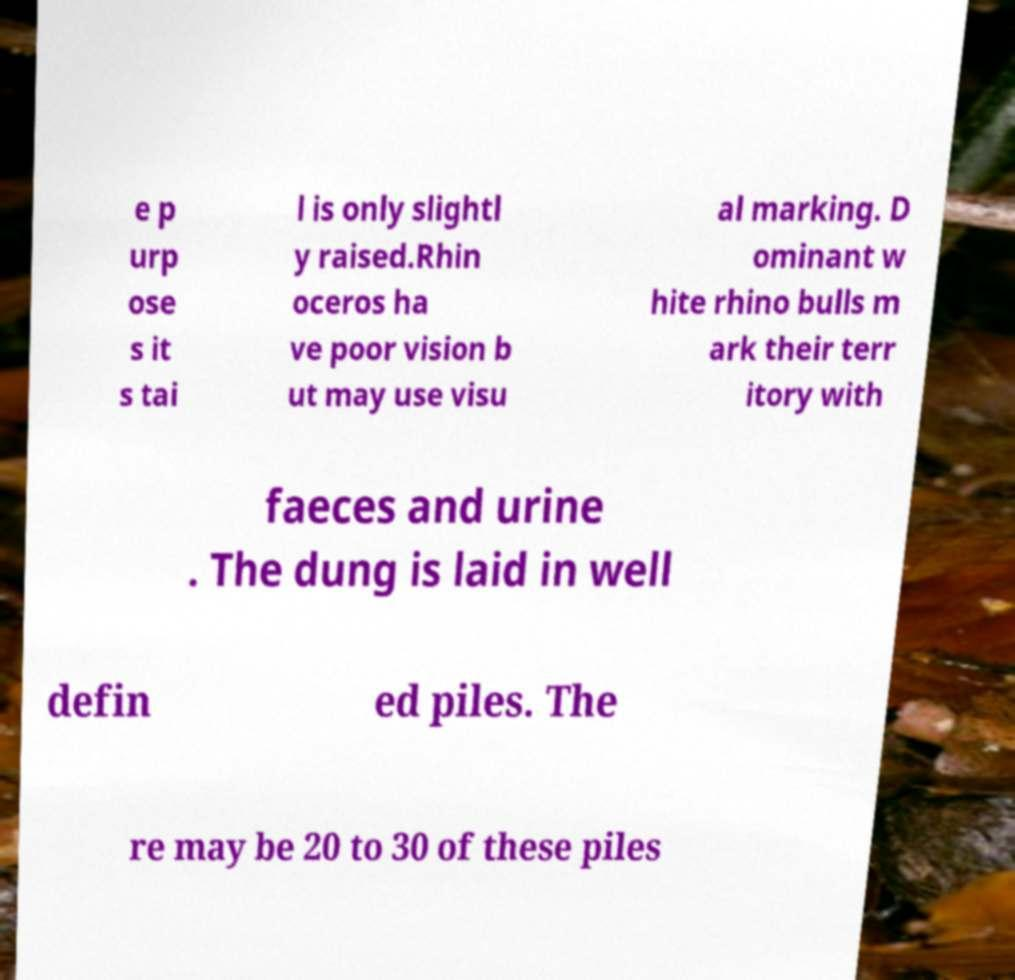Can you accurately transcribe the text from the provided image for me? e p urp ose s it s tai l is only slightl y raised.Rhin oceros ha ve poor vision b ut may use visu al marking. D ominant w hite rhino bulls m ark their terr itory with faeces and urine . The dung is laid in well defin ed piles. The re may be 20 to 30 of these piles 